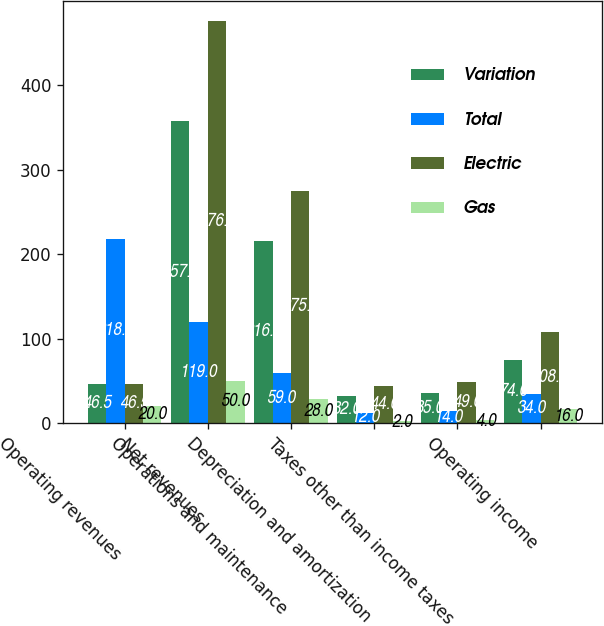Convert chart. <chart><loc_0><loc_0><loc_500><loc_500><stacked_bar_chart><ecel><fcel>Operating revenues<fcel>Net revenues<fcel>Operations and maintenance<fcel>Depreciation and amortization<fcel>Taxes other than income taxes<fcel>Operating income<nl><fcel>Variation<fcel>46.5<fcel>357<fcel>216<fcel>32<fcel>35<fcel>74<nl><fcel>Total<fcel>218<fcel>119<fcel>59<fcel>12<fcel>14<fcel>34<nl><fcel>Electric<fcel>46.5<fcel>476<fcel>275<fcel>44<fcel>49<fcel>108<nl><fcel>Gas<fcel>20<fcel>50<fcel>28<fcel>2<fcel>4<fcel>16<nl></chart> 